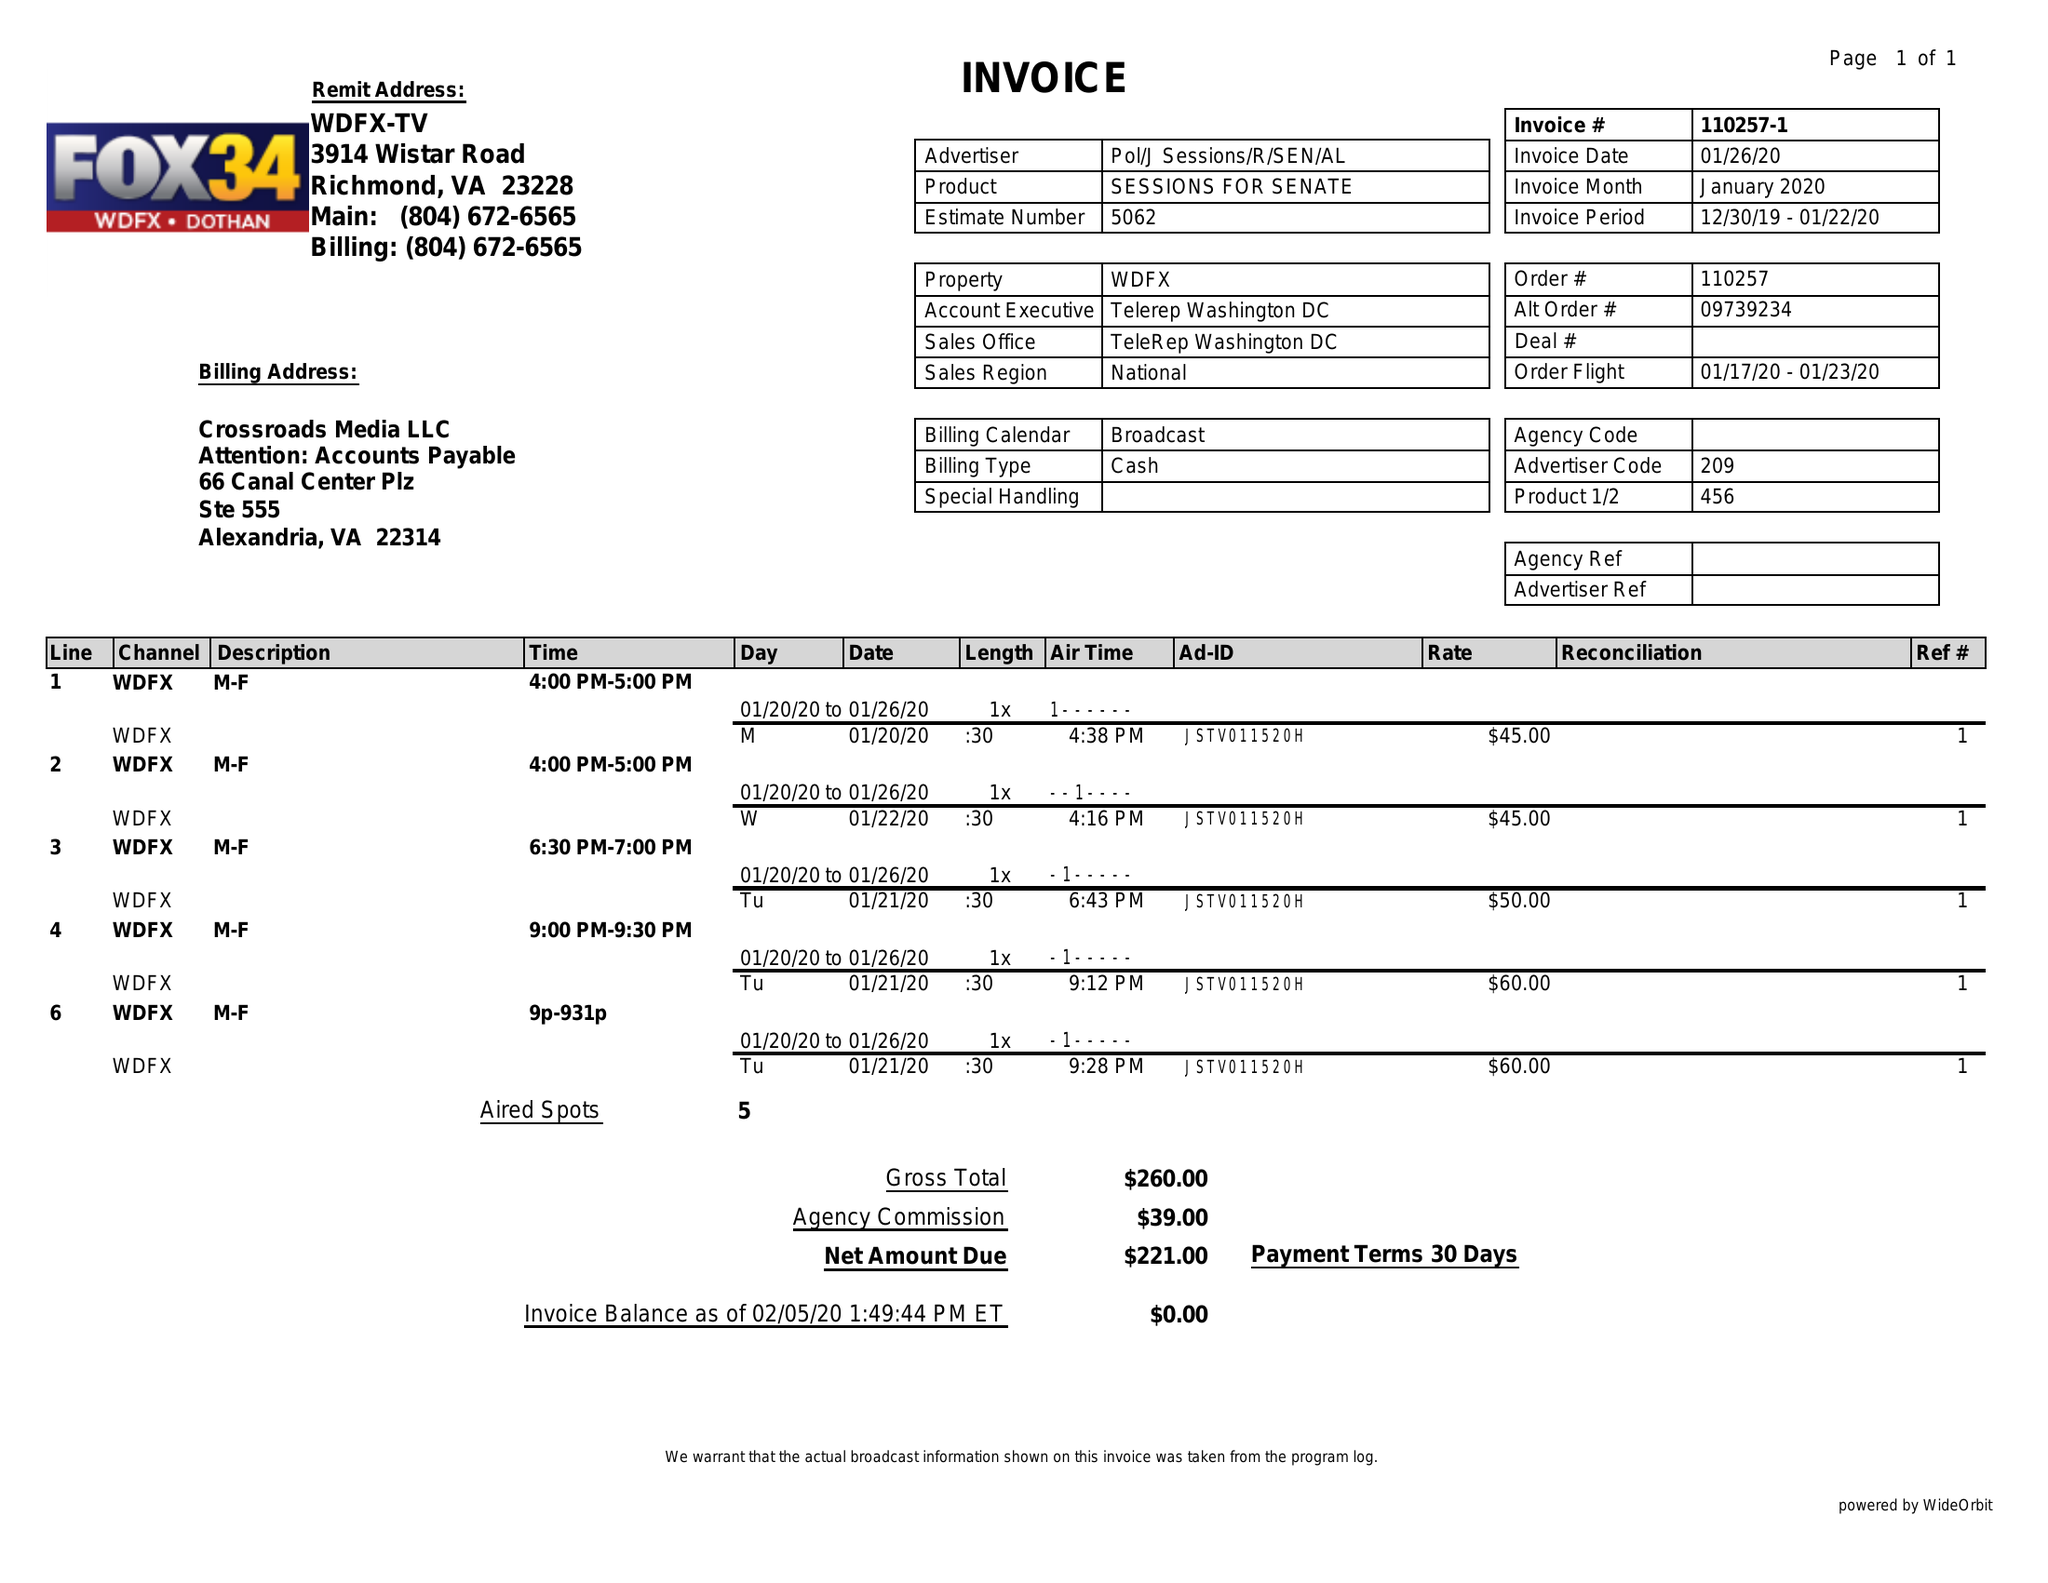What is the value for the gross_amount?
Answer the question using a single word or phrase. 260.00 